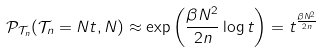<formula> <loc_0><loc_0><loc_500><loc_500>\mathcal { P } _ { \mathcal { T } _ { n } } ( \mathcal { T } _ { n } = N t , N ) \approx \exp \left ( \frac { \beta N ^ { 2 } } { 2 n } \log t \right ) = t ^ { \frac { \beta N ^ { 2 } } { 2 n } }</formula> 